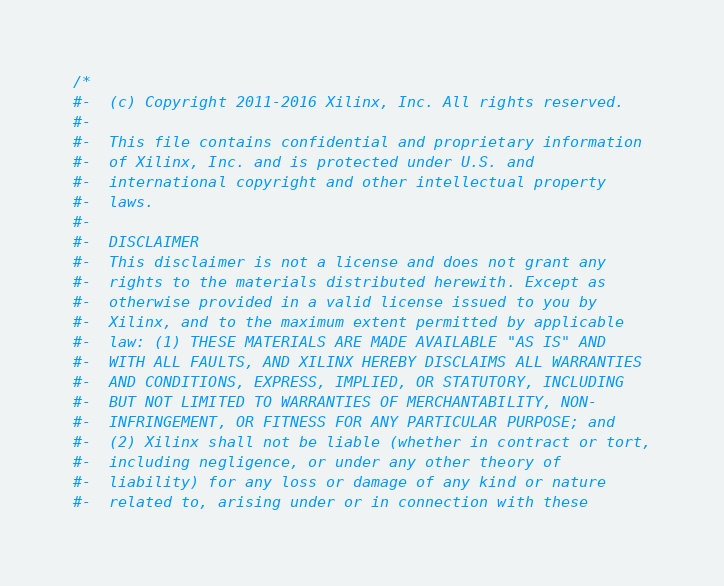<code> <loc_0><loc_0><loc_500><loc_500><_C_>/*
#-  (c) Copyright 2011-2016 Xilinx, Inc. All rights reserved.
#-
#-  This file contains confidential and proprietary information
#-  of Xilinx, Inc. and is protected under U.S. and
#-  international copyright and other intellectual property
#-  laws.
#-
#-  DISCLAIMER
#-  This disclaimer is not a license and does not grant any
#-  rights to the materials distributed herewith. Except as
#-  otherwise provided in a valid license issued to you by
#-  Xilinx, and to the maximum extent permitted by applicable
#-  law: (1) THESE MATERIALS ARE MADE AVAILABLE "AS IS" AND
#-  WITH ALL FAULTS, AND XILINX HEREBY DISCLAIMS ALL WARRANTIES
#-  AND CONDITIONS, EXPRESS, IMPLIED, OR STATUTORY, INCLUDING
#-  BUT NOT LIMITED TO WARRANTIES OF MERCHANTABILITY, NON-
#-  INFRINGEMENT, OR FITNESS FOR ANY PARTICULAR PURPOSE; and
#-  (2) Xilinx shall not be liable (whether in contract or tort,
#-  including negligence, or under any other theory of
#-  liability) for any loss or damage of any kind or nature
#-  related to, arising under or in connection with these</code> 